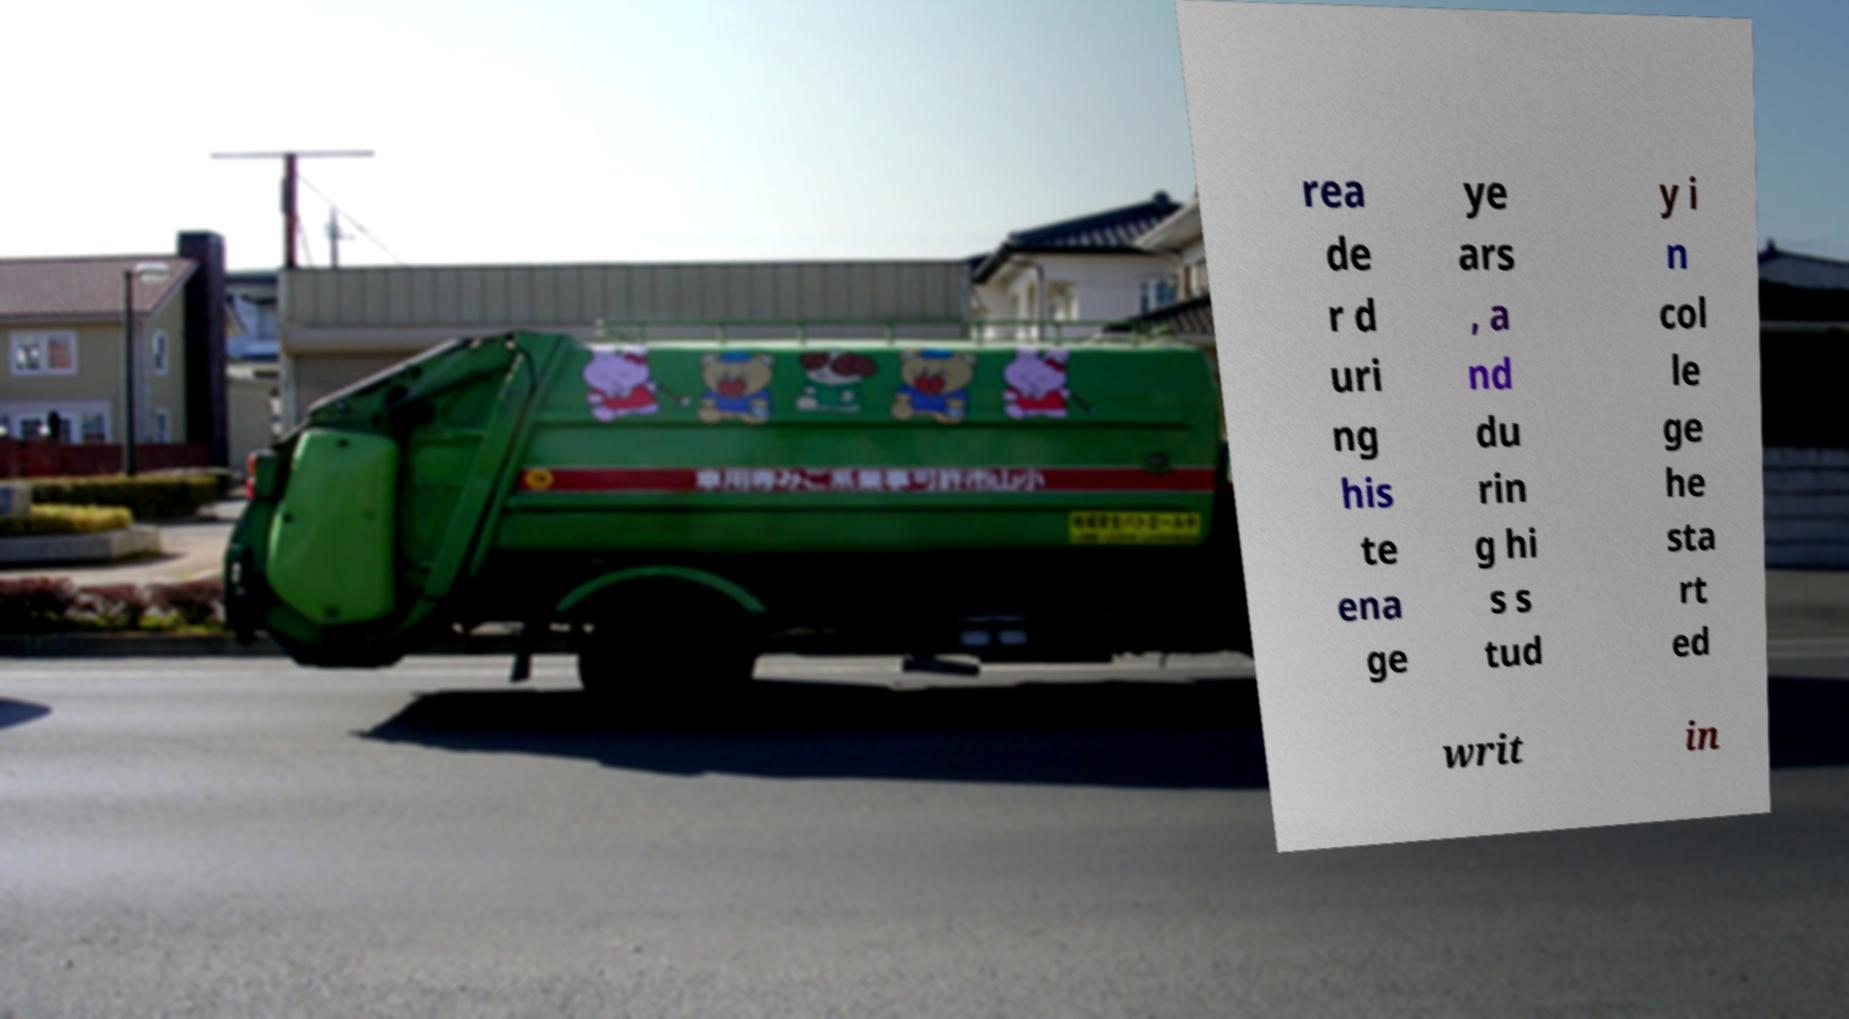For documentation purposes, I need the text within this image transcribed. Could you provide that? rea de r d uri ng his te ena ge ye ars , a nd du rin g hi s s tud y i n col le ge he sta rt ed writ in 